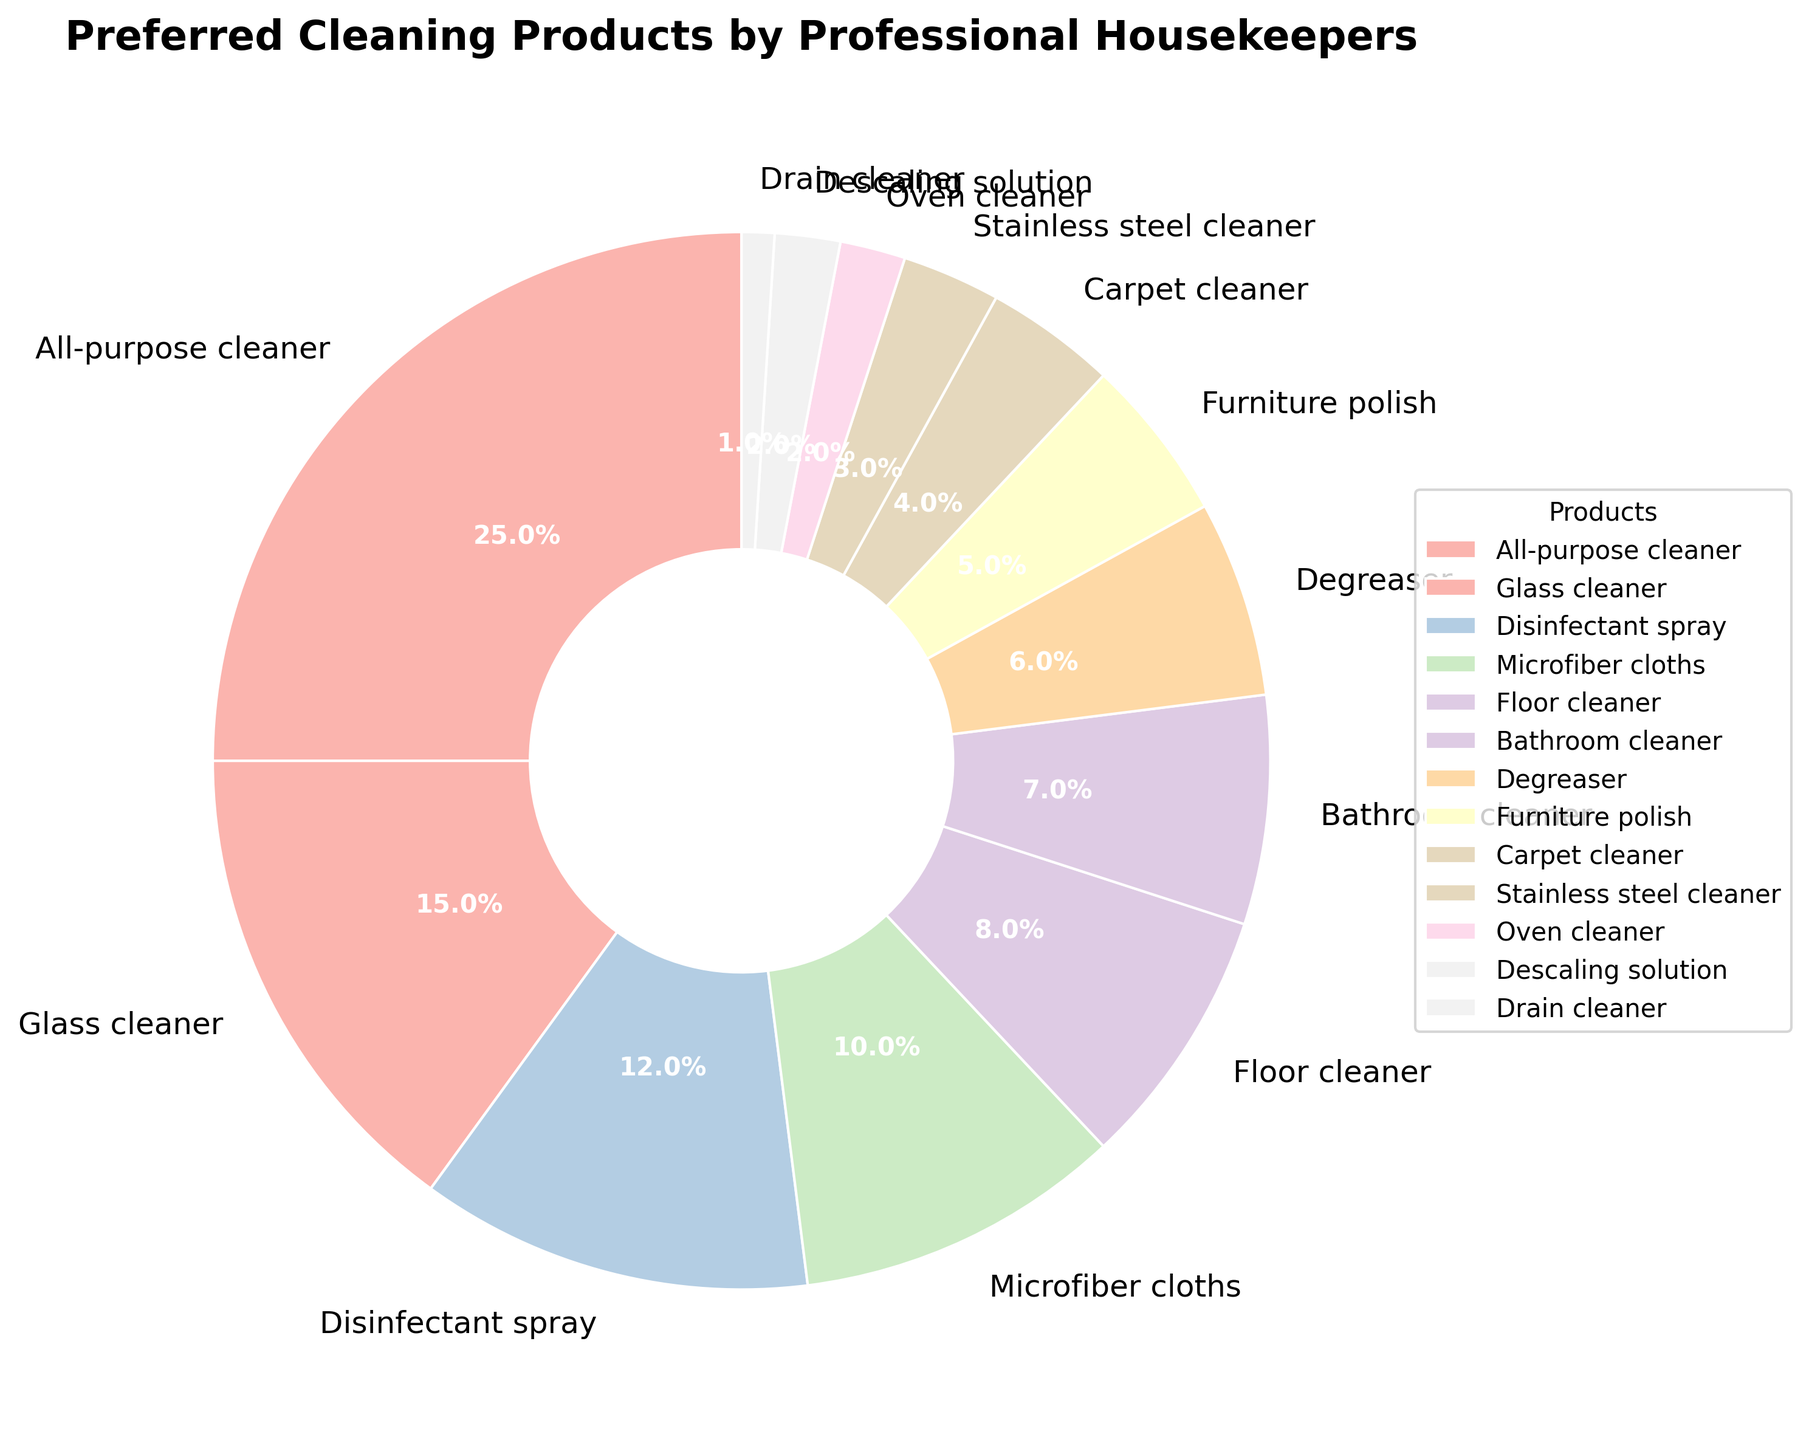Which product is preferred the most by professional housekeepers? The largest wedge in the pie chart, representing the highest percentage, corresponds to the All-purpose cleaner.
Answer: All-purpose cleaner What percentage of professional housekeepers prefer glass cleaner and bathroom cleaner combined? The percentage for glass cleaner is 15%, and for bathroom cleaner is 7%. Summing these up results in 15% + 7% = 22%.
Answer: 22% How does the preference for microfiber cloths compare to that of disinfectant spray? The percentage for microfiber cloths is 10%, and for disinfectant spray is 12%. Therefore, disinfectant spray is preferred more than microfiber cloths.
Answer: Disinfectant spray Identify the cleaning product with the smallest preference among professional housekeepers. The smallest wedge in the pie chart, representing the lowest percentage, corresponds to the Drain cleaner.
Answer: Drain cleaner Which products have a preference of less than 5%? By examining the wedges in the pie chart, the products with less than 5% preference are Carpet cleaner, Stainless steel cleaner, Oven cleaner, Descaling solution, and Drain cleaner.
Answer: Carpet cleaner, Stainless steel cleaner, Oven cleaner, Descaling solution, Drain cleaner Sum the percentages of the top three most preferred cleaning products. The top three cleaning products by preference are All-purpose cleaner (25%), Glass cleaner (15%), and Disinfectant spray (12%). Summing these gives 25% + 15% + 12% = 52%.
Answer: 52% How much more preferred is the floor cleaner compared to the furniture polish? The percentage for floor cleaner is 8%, and for furniture polish is 5%. The difference is 8% - 5% = 3%.
Answer: 3% Which products have the same level of preference according to the pie chart? The pie chart shows that both Oven cleaner and Descaling solution have the same percentage of 2%.
Answer: Oven cleaner, Descaling solution What is the combined preference percentage of the degreaser and furniture polish? The percentage for degreaser is 6%, and for furniture polish is 5%. Summing these gives 6% + 5% = 11%.
Answer: 11% 